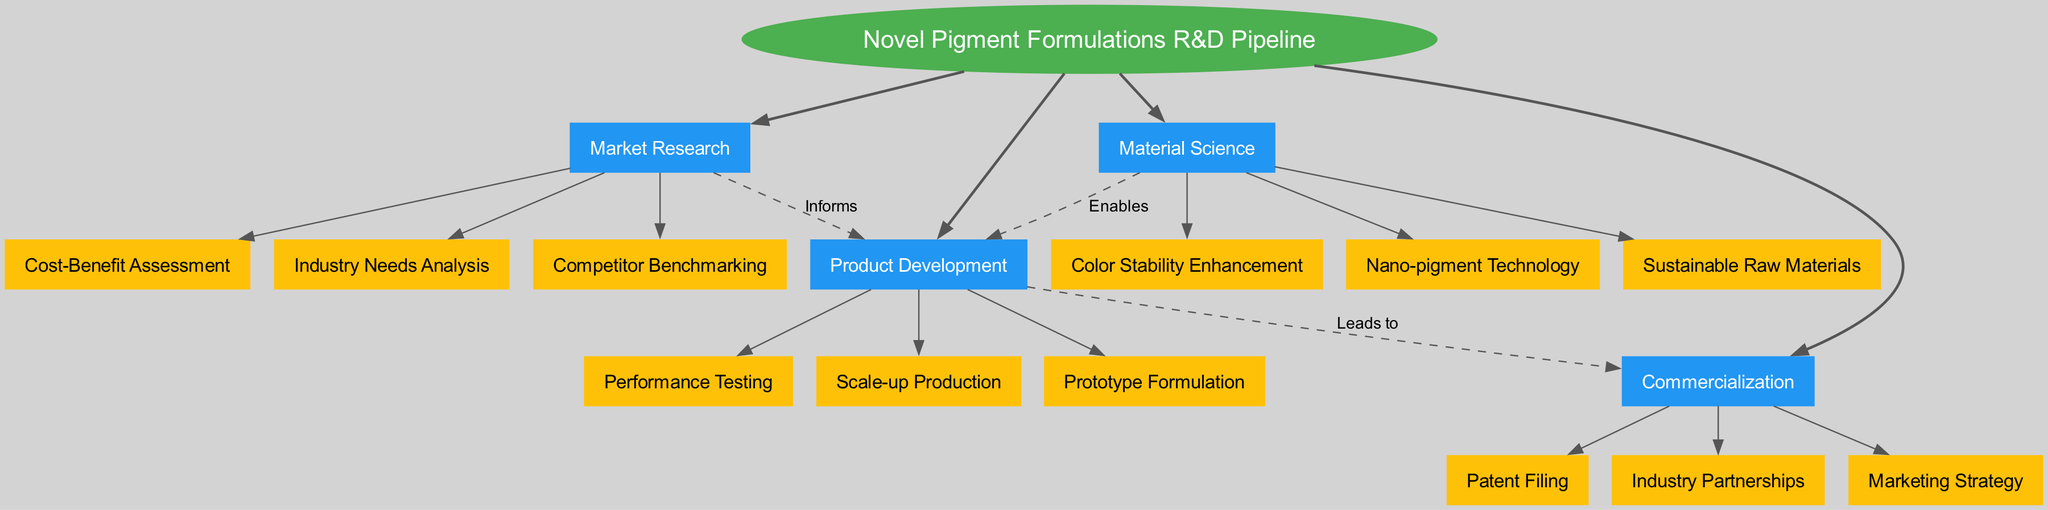What is the central concept of the diagram? The diagram's central concept is labeled at its core as "Novel Pigment Formulations R&D Pipeline," which represents the main theme of the concept map.
Answer: Novel Pigment Formulations R&D Pipeline How many main branches are present in the diagram? The diagram consists of four main branches listed, which are "Market Research," "Material Science," "Product Development," and "Commercialization."
Answer: 4 What sub-branch is associated with the "Market Research"? Under the "Market Research" branch, there are three sub-branches. One of them is "Industry Needs Analysis," which is an essential aspect of understanding the market.
Answer: Industry Needs Analysis Which branch enables product development through material science? The "Material Science" branch is indicated to enable the "Product Development" branch, showing the direct relationship where material innovations facilitate product creation.
Answer: Material Science What relationship does "Market Research" have with "Product Development"? There is a connection labeled "Informs," indicating that the "Market Research" branch provides insights and information that guide and influence "Product Development."
Answer: Informs Which sub-branch of "Commercialization" focuses on partnerships? The "Industry Partnerships" is a sub-branch under "Commercialization," emphasizing strategic collaborations as part of the commercialization process for novel pigment formulations.
Answer: Industry Partnerships What is the last branch in the R&D pipeline leading to commercialization? The last branch that directly leads to commercialization, as per the flow of the diagram, is "Product Development," which is crucial for transitioning from development to market availability.
Answer: Product Development What does the "Nano-pigment Technology" support in the diagram? The "Nano-pigment Technology" is a sub-branch under "Material Science," which ultimately supports the "Product Development," indicating its role in creating new products.
Answer: Product Development Which two branches are connected by a dashed line indicating their relationship? The "Product Development" and "Commercialization" branches are connected with a dashed line labeled "Leads to," indicating a progression from product innovation to market availability.
Answer: Product Development and Commercialization 